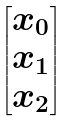Convert formula to latex. <formula><loc_0><loc_0><loc_500><loc_500>\begin{bmatrix} x _ { 0 } \\ x _ { 1 } \\ x _ { 2 } \end{bmatrix}</formula> 